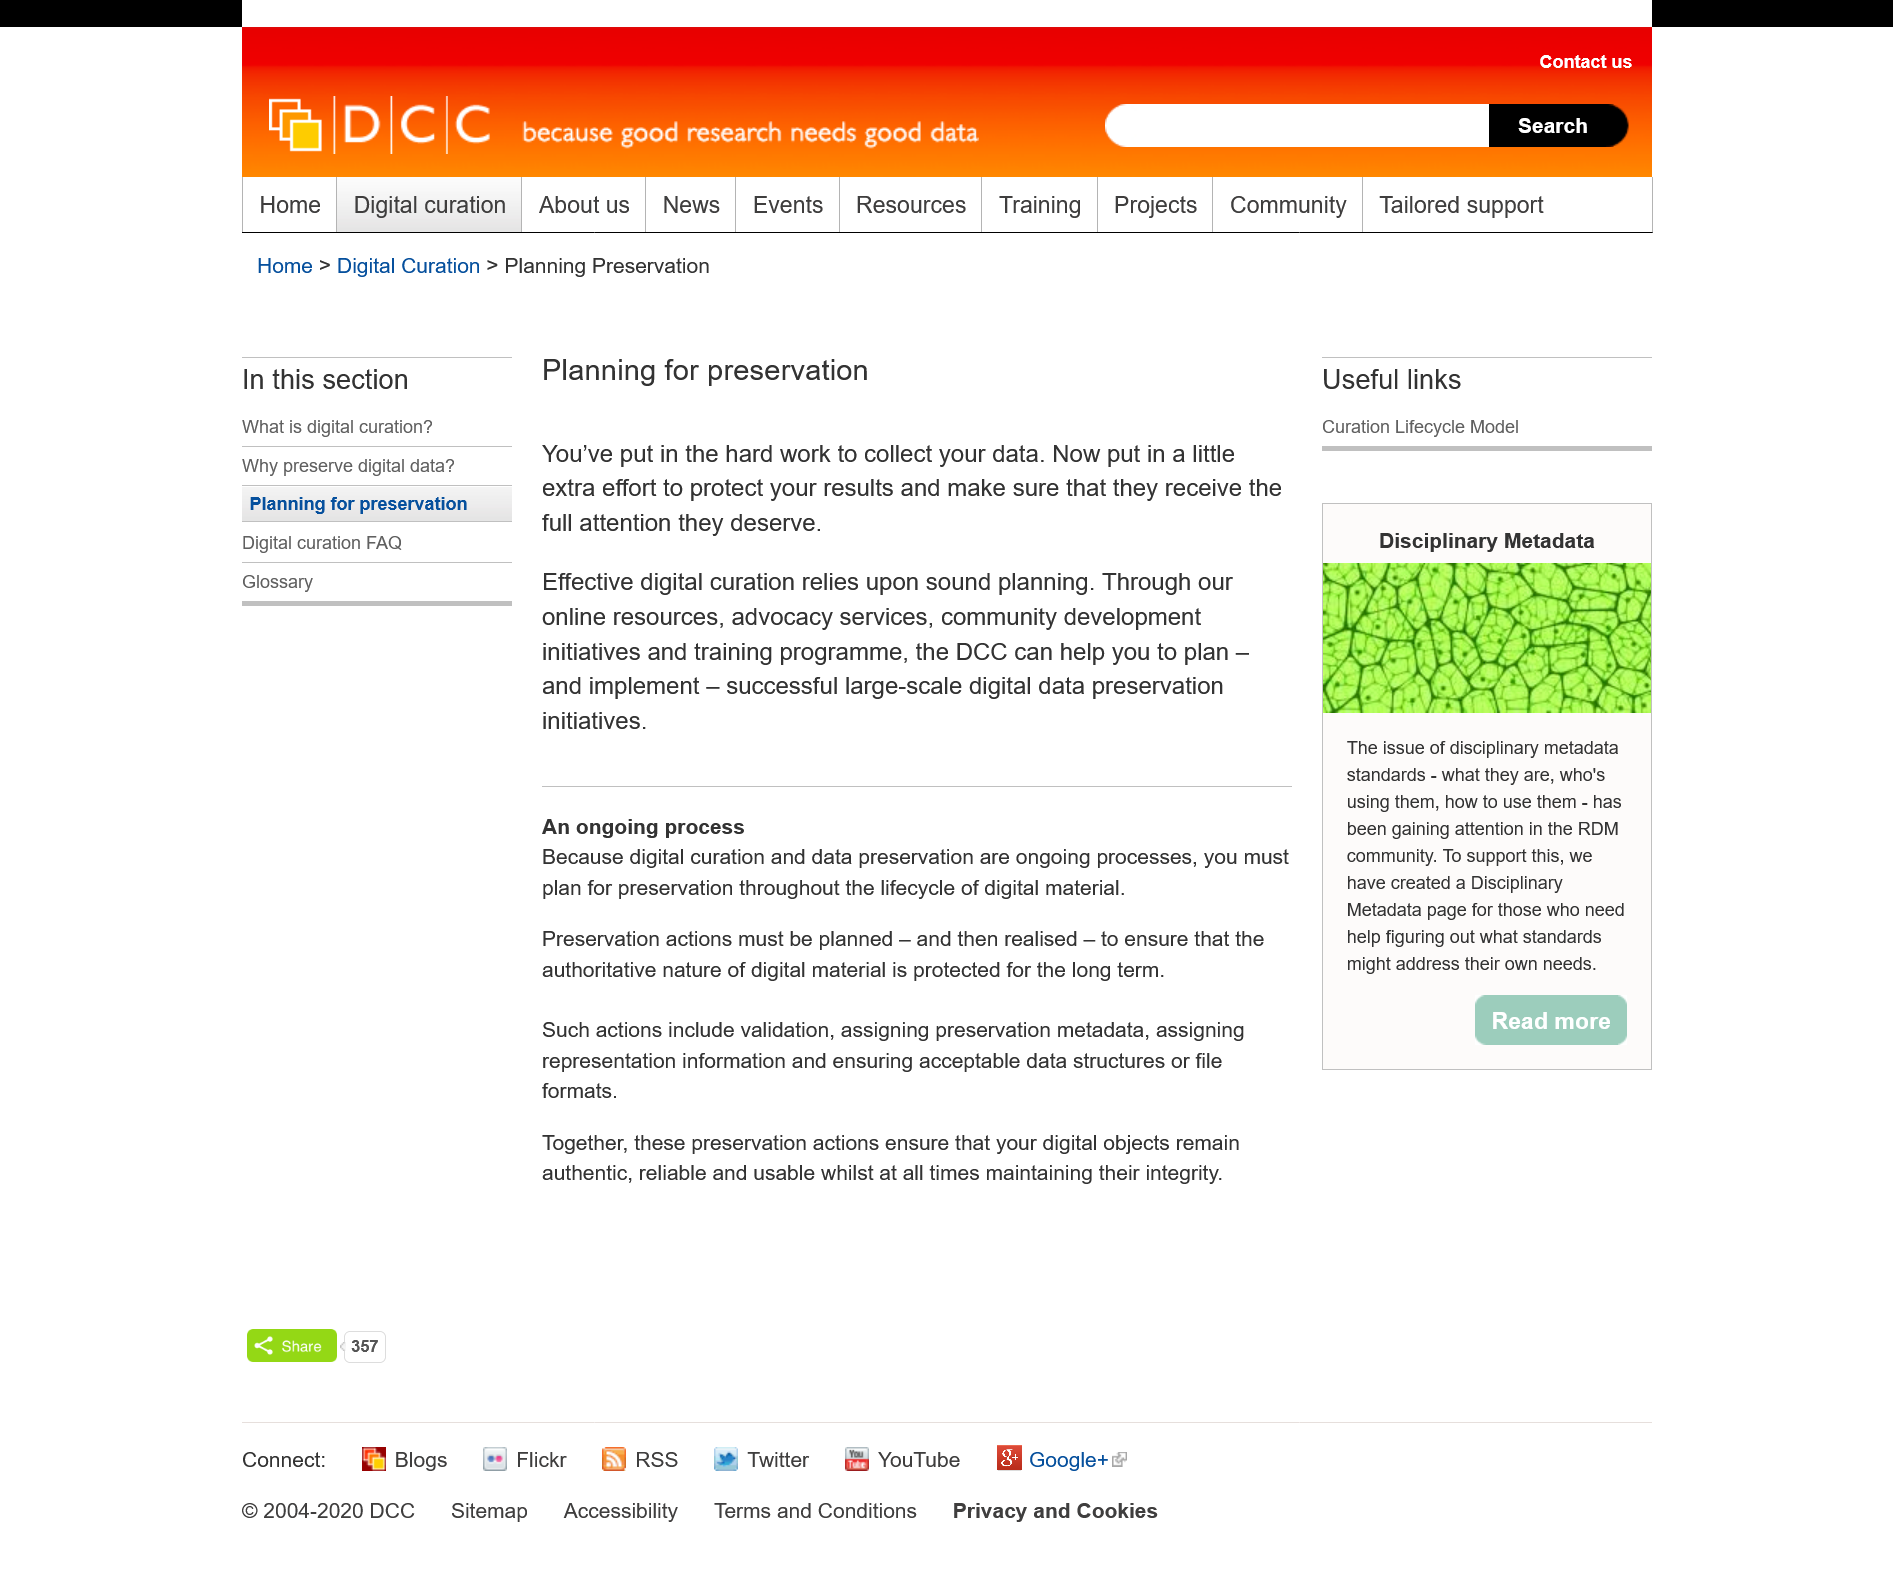Indicate a few pertinent items in this graphic. The DCC provides advocacy services as one of the things it does to help with planning for preservation. The Digital Preservation Coalition (DCC) will help the Digital Preservation Program (DPP) plan and implement preservation initiatives. Effective digital curation requires sound planning, which is essential for its success. 